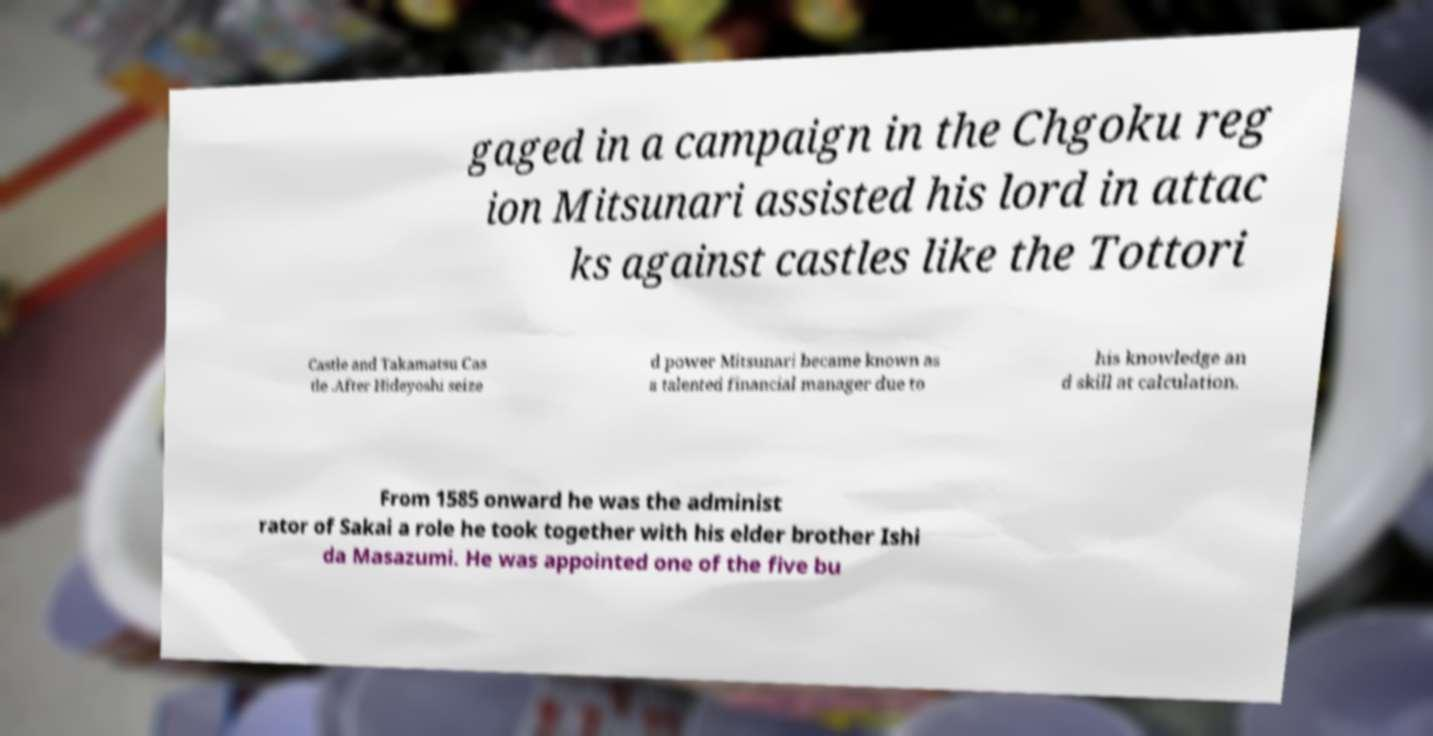Please read and relay the text visible in this image. What does it say? gaged in a campaign in the Chgoku reg ion Mitsunari assisted his lord in attac ks against castles like the Tottori Castle and Takamatsu Cas tle .After Hideyoshi seize d power Mitsunari became known as a talented financial manager due to his knowledge an d skill at calculation. From 1585 onward he was the administ rator of Sakai a role he took together with his elder brother Ishi da Masazumi. He was appointed one of the five bu 